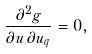Convert formula to latex. <formula><loc_0><loc_0><loc_500><loc_500>\frac { \partial ^ { 2 } g } { \partial u \, \partial u _ { q } } = 0 ,</formula> 